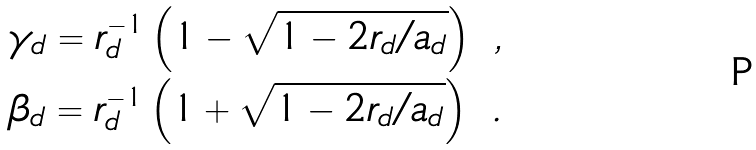<formula> <loc_0><loc_0><loc_500><loc_500>\gamma _ { d } = r _ { d } ^ { - 1 } \left ( 1 - \sqrt { 1 - 2 r _ { d } / a _ { d } } \right ) \ , \\ \beta _ { d } = r _ { d } ^ { - 1 } \left ( 1 + \sqrt { 1 - 2 r _ { d } / a _ { d } } \right ) \ .</formula> 